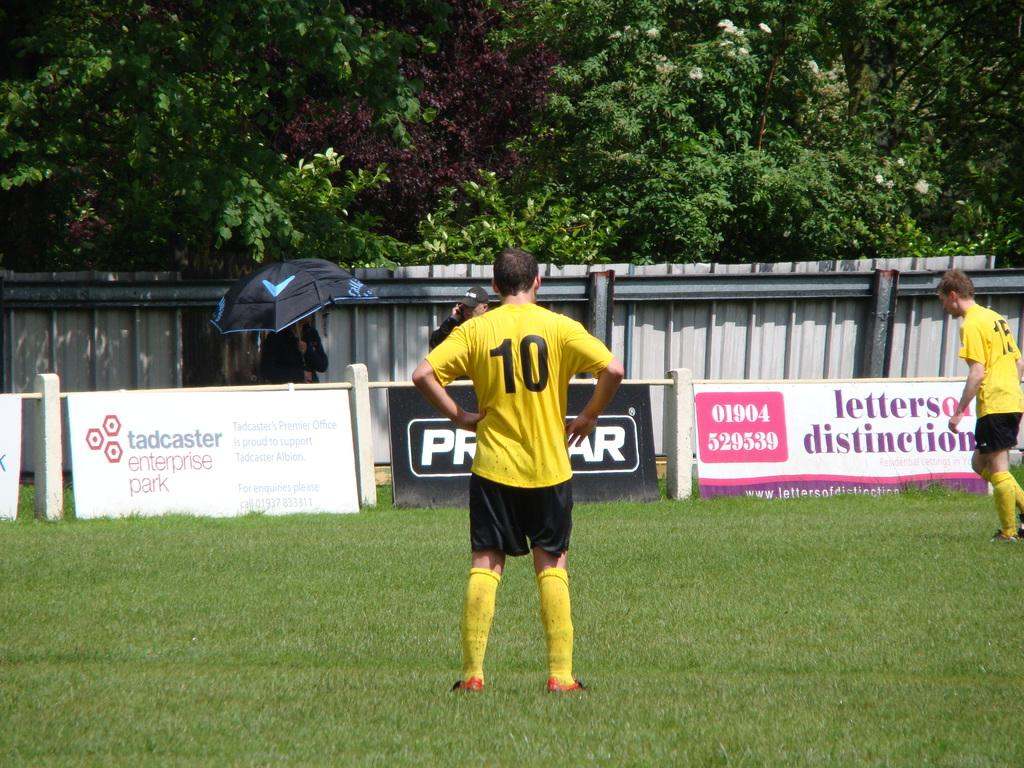How many people are in the image? There are four persons in the image. What is the ground surface like in the image? There is grass on the ground in the image. What type of vegetation can be seen in the image? There are trees visible at the top of the image. What is present in the middle of the image? There is some text in the middle of the image. What type of mine is visible in the image? There is no mine present in the image. What is the belief system of the persons in the image? The provided facts do not give any information about the belief system of the persons in the image. 